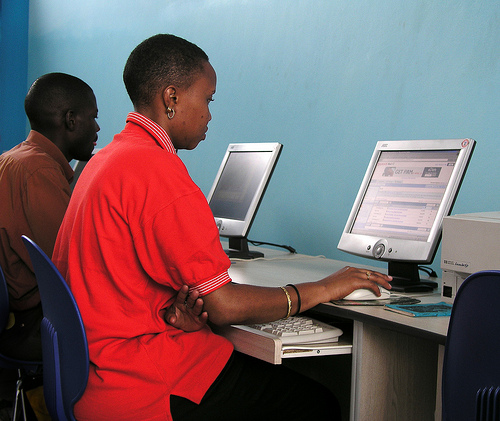<image>
Is the keyboard under the table? Yes. The keyboard is positioned underneath the table, with the table above it in the vertical space. 